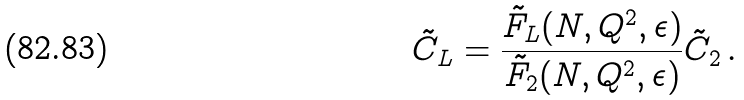<formula> <loc_0><loc_0><loc_500><loc_500>\tilde { C } _ { L } = \frac { \tilde { F } _ { L } ( N , Q ^ { 2 } , \epsilon ) } { \tilde { F } _ { 2 } ( N , Q ^ { 2 } , \epsilon ) } \tilde { C } _ { 2 } \, .</formula> 